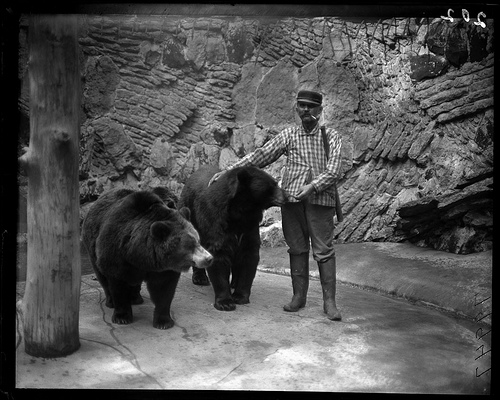What are the bears doing in this picture? The bears in this historical image are walking closely with the man, indicating they are possibly trained or at least very accustomed to human presence. There's no sign of aggressive behavior; instead, they exhibit calmness and a controlled demeanor, which is fascinating considering their size and natural instincts. What can we infer about the bears' behavior towards humans? The bears' behavior, walking peacefully next to the man, suggests that they have been conditioned to be around humans. This indicates extensive training and possibly a specialized care that they receive to maintain such composure, demonstrating a significant aspect of wildlife management in controlled settings. 